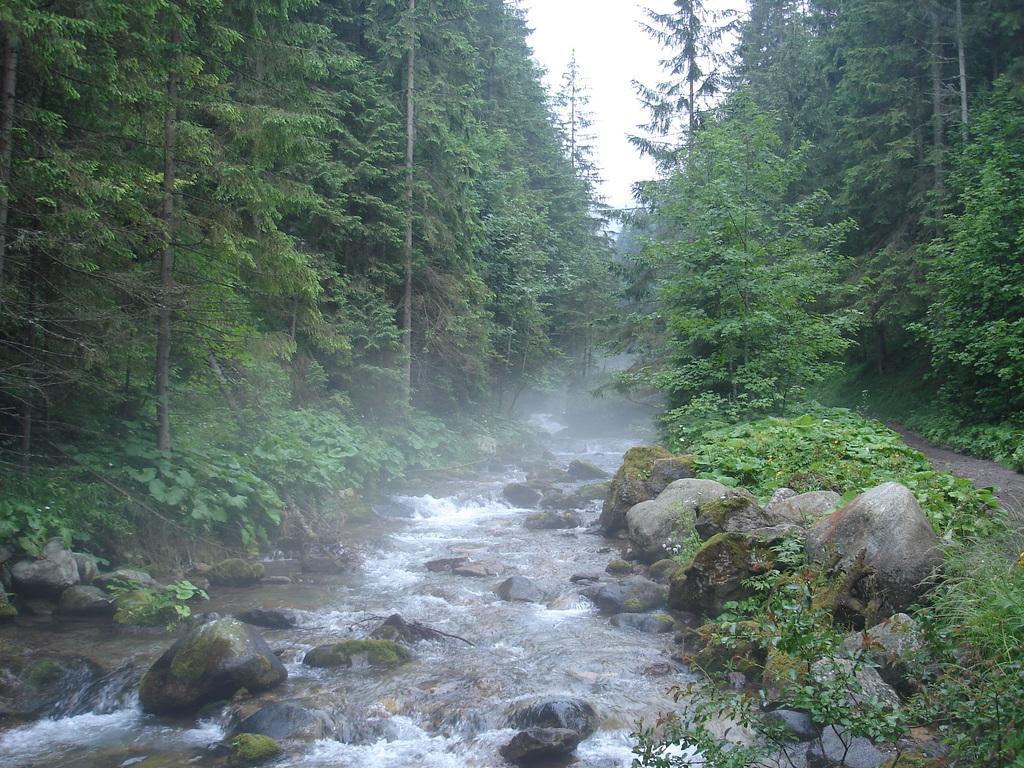Describe this image in one or two sentences. In this image we can see the river, rocks, there are plants, trees, also we can see the sky. 